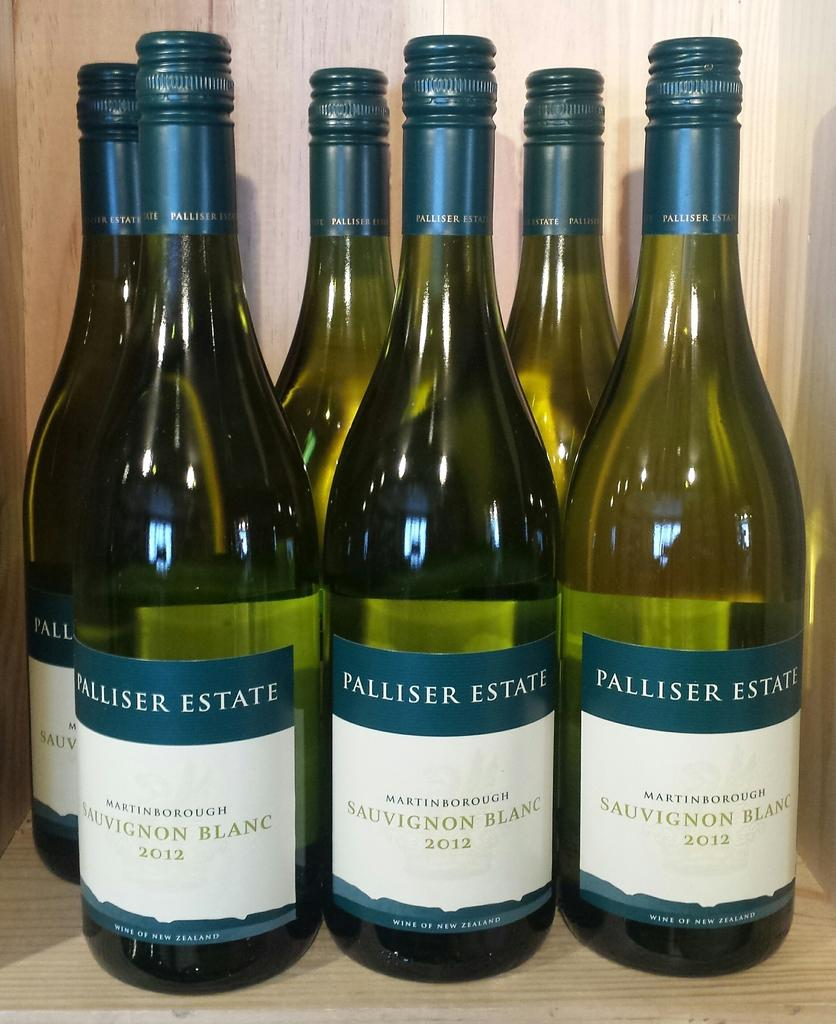What type of bottles are present in the image? There are wine bottles in the image. What year is written on the wine bottles? The wine bottles have the year 2012 written on them. How many wine bottles are there in total? There are six wine bottles in total. On what surface are the wine bottles placed? The wine bottles are placed on a wooden table. What flavor of basketball can be seen in the image? There is no basketball present in the image, so it is not possible to determine the flavor of a basketball. 